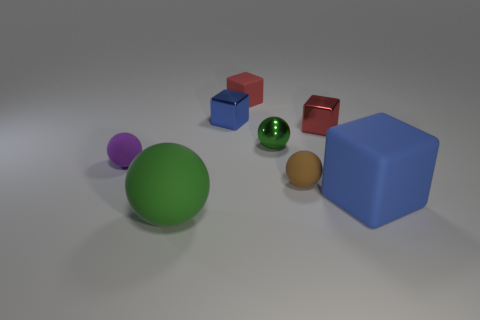What is the size of the object that is the same color as the large rubber ball?
Provide a succinct answer. Small. What is the color of the large block?
Your answer should be very brief. Blue. There is a brown object that is made of the same material as the large green object; what is its size?
Your response must be concise. Small. How many green rubber balls are left of the matte thing in front of the block that is in front of the purple object?
Your answer should be compact. 0. Is the color of the large cube the same as the small metal block on the left side of the small brown rubber ball?
Ensure brevity in your answer.  Yes. There is a matte thing that is the same color as the metal sphere; what is its shape?
Offer a terse response. Sphere. What is the material of the blue thing behind the tiny rubber ball left of the red block left of the green metal thing?
Ensure brevity in your answer.  Metal. There is a green thing right of the big rubber ball; does it have the same shape as the brown object?
Your answer should be very brief. Yes. There is a large object that is behind the big rubber ball; what is it made of?
Ensure brevity in your answer.  Rubber. What number of metallic things are tiny purple spheres or blue blocks?
Keep it short and to the point. 1. 